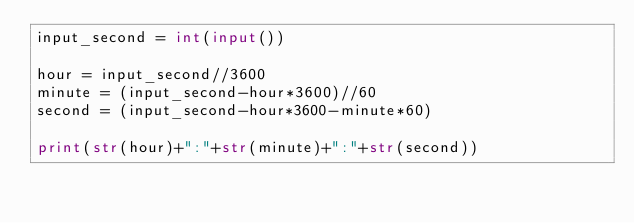<code> <loc_0><loc_0><loc_500><loc_500><_Python_>input_second = int(input())

hour = input_second//3600
minute = (input_second-hour*3600)//60
second = (input_second-hour*3600-minute*60)

print(str(hour)+":"+str(minute)+":"+str(second))
</code> 